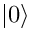Convert formula to latex. <formula><loc_0><loc_0><loc_500><loc_500>| 0 \rangle</formula> 